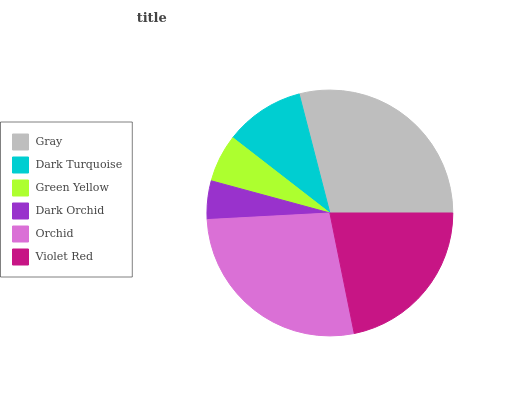Is Dark Orchid the minimum?
Answer yes or no. Yes. Is Gray the maximum?
Answer yes or no. Yes. Is Dark Turquoise the minimum?
Answer yes or no. No. Is Dark Turquoise the maximum?
Answer yes or no. No. Is Gray greater than Dark Turquoise?
Answer yes or no. Yes. Is Dark Turquoise less than Gray?
Answer yes or no. Yes. Is Dark Turquoise greater than Gray?
Answer yes or no. No. Is Gray less than Dark Turquoise?
Answer yes or no. No. Is Violet Red the high median?
Answer yes or no. Yes. Is Dark Turquoise the low median?
Answer yes or no. Yes. Is Dark Turquoise the high median?
Answer yes or no. No. Is Violet Red the low median?
Answer yes or no. No. 